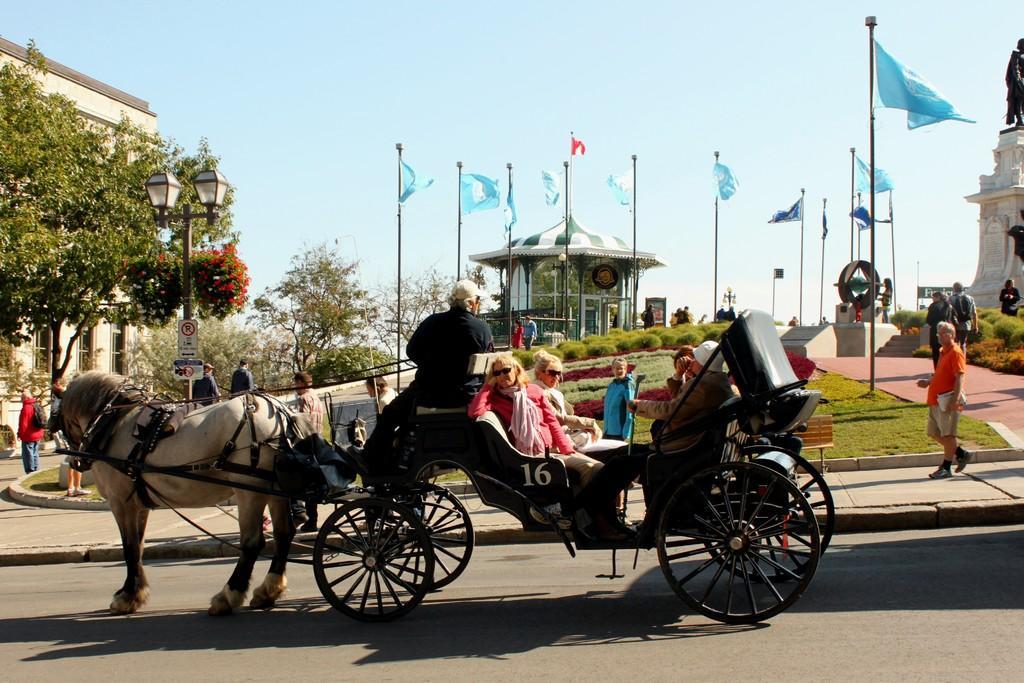How would you summarize this image in a sentence or two? In this image we can see people sitting in the horse drawn vehicle on the road. In the background we can see the building and also the house for shelter and a monument on the right. Image also consists of trees and also flags. We can also see the light pole. Grass is also visible in this image. At the top there is sky. 